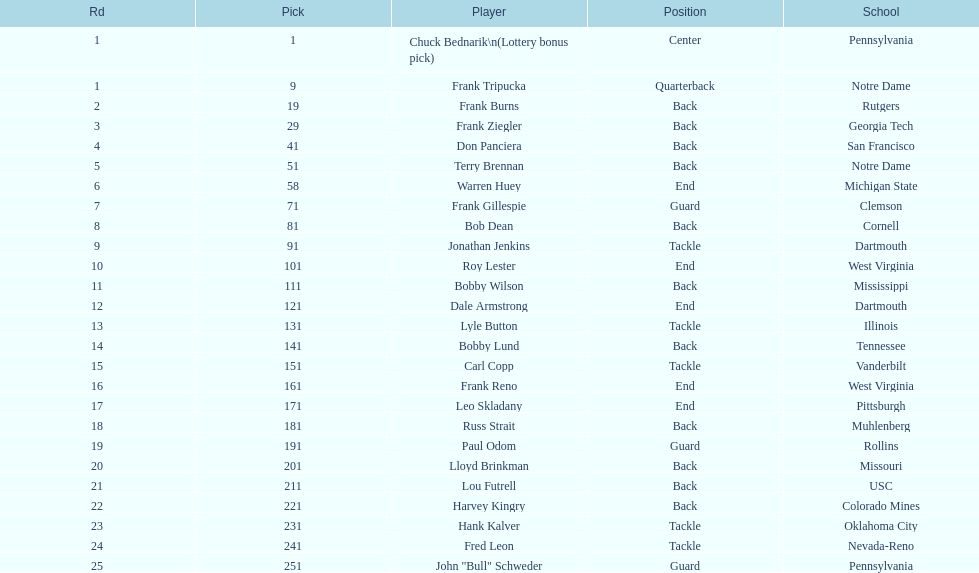Who was picked after roy lester? Bobby Wilson. 